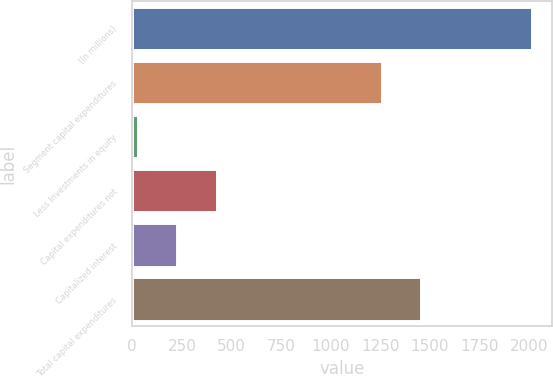Convert chart to OTSL. <chart><loc_0><loc_0><loc_500><loc_500><bar_chart><fcel>(In millions)<fcel>Segment capital expenditures<fcel>Less Investments in equity<fcel>Capital expenditures not<fcel>Capitalized interest<fcel>Total capital expenditures<nl><fcel>2012<fcel>1256<fcel>28<fcel>424.8<fcel>226.4<fcel>1454.4<nl></chart> 